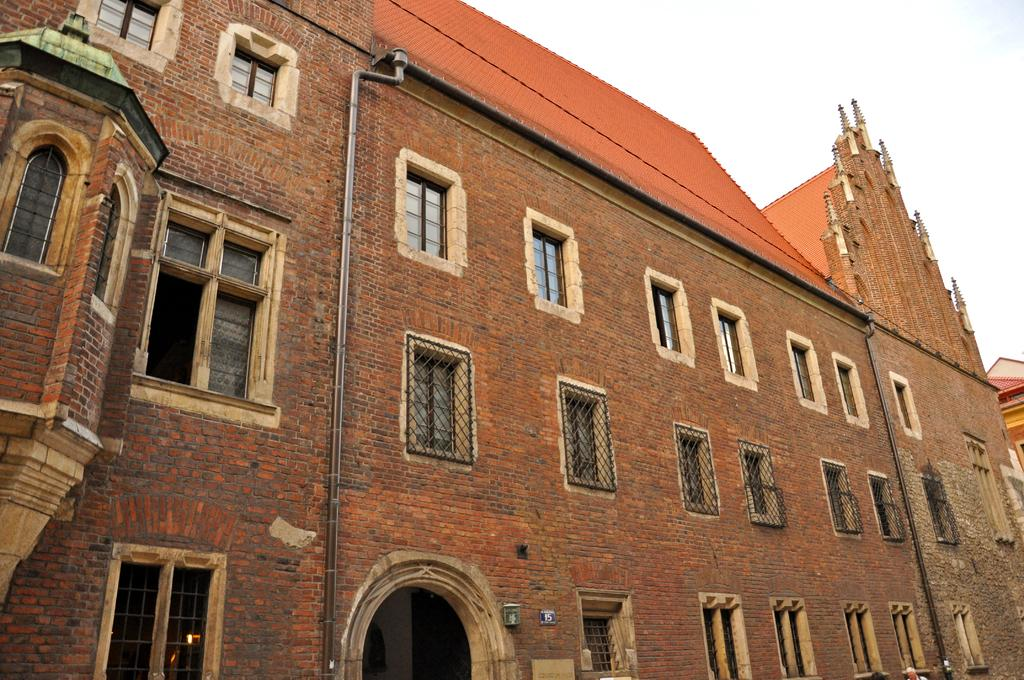What type of structure is present in the image? There is a building in the image. What is the color of the building? The building is brown in color. Are there any specific features on the building? Yes, there are windows on the building. What else can be seen in the image besides the building? There are pipes visible in the image. What is visible in the background of the image? The sky is visible in the background of the image. Can you tell me where your uncle is standing in the image? There is no uncle present in the image, as it only features a building, pipes, and the sky. 